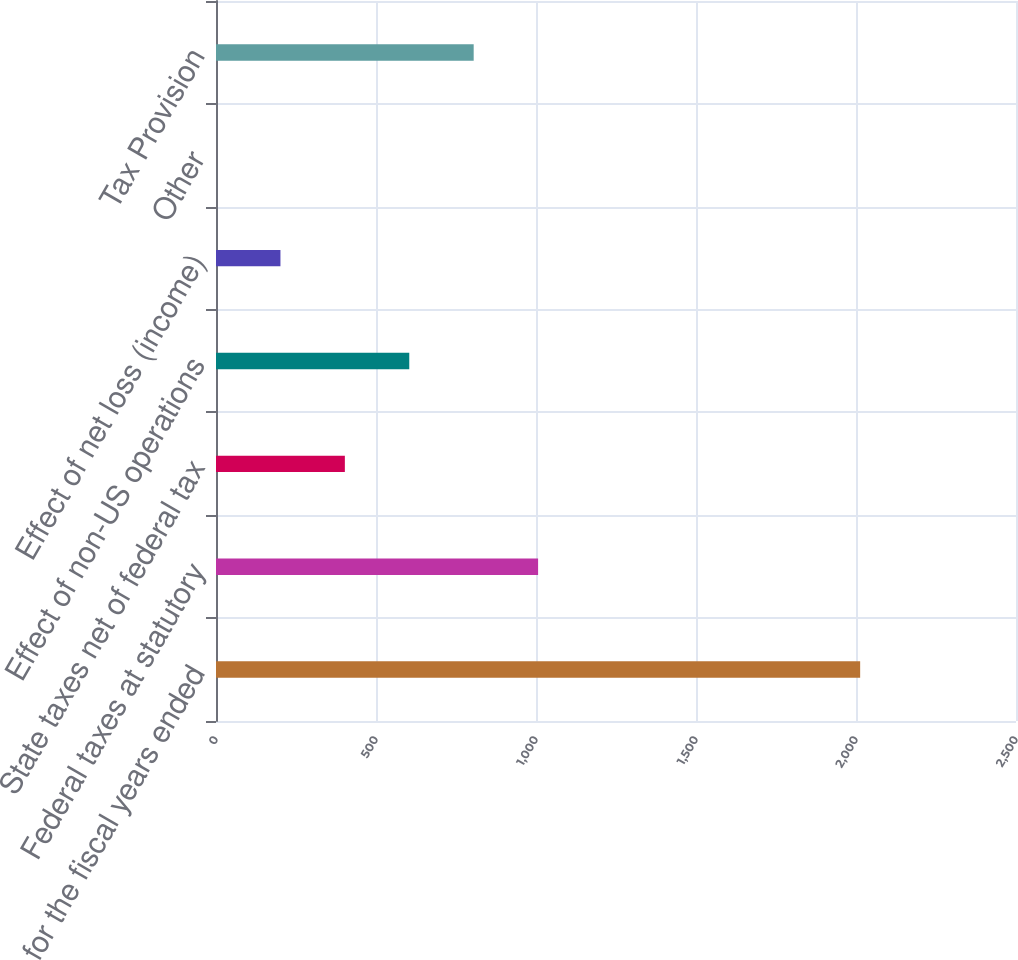<chart> <loc_0><loc_0><loc_500><loc_500><bar_chart><fcel>for the fiscal years ended<fcel>Federal taxes at statutory<fcel>State taxes net of federal tax<fcel>Effect of non-US operations<fcel>Effect of net loss (income)<fcel>Other<fcel>Tax Provision<nl><fcel>2013<fcel>1006.55<fcel>402.68<fcel>603.97<fcel>201.39<fcel>0.1<fcel>805.26<nl></chart> 